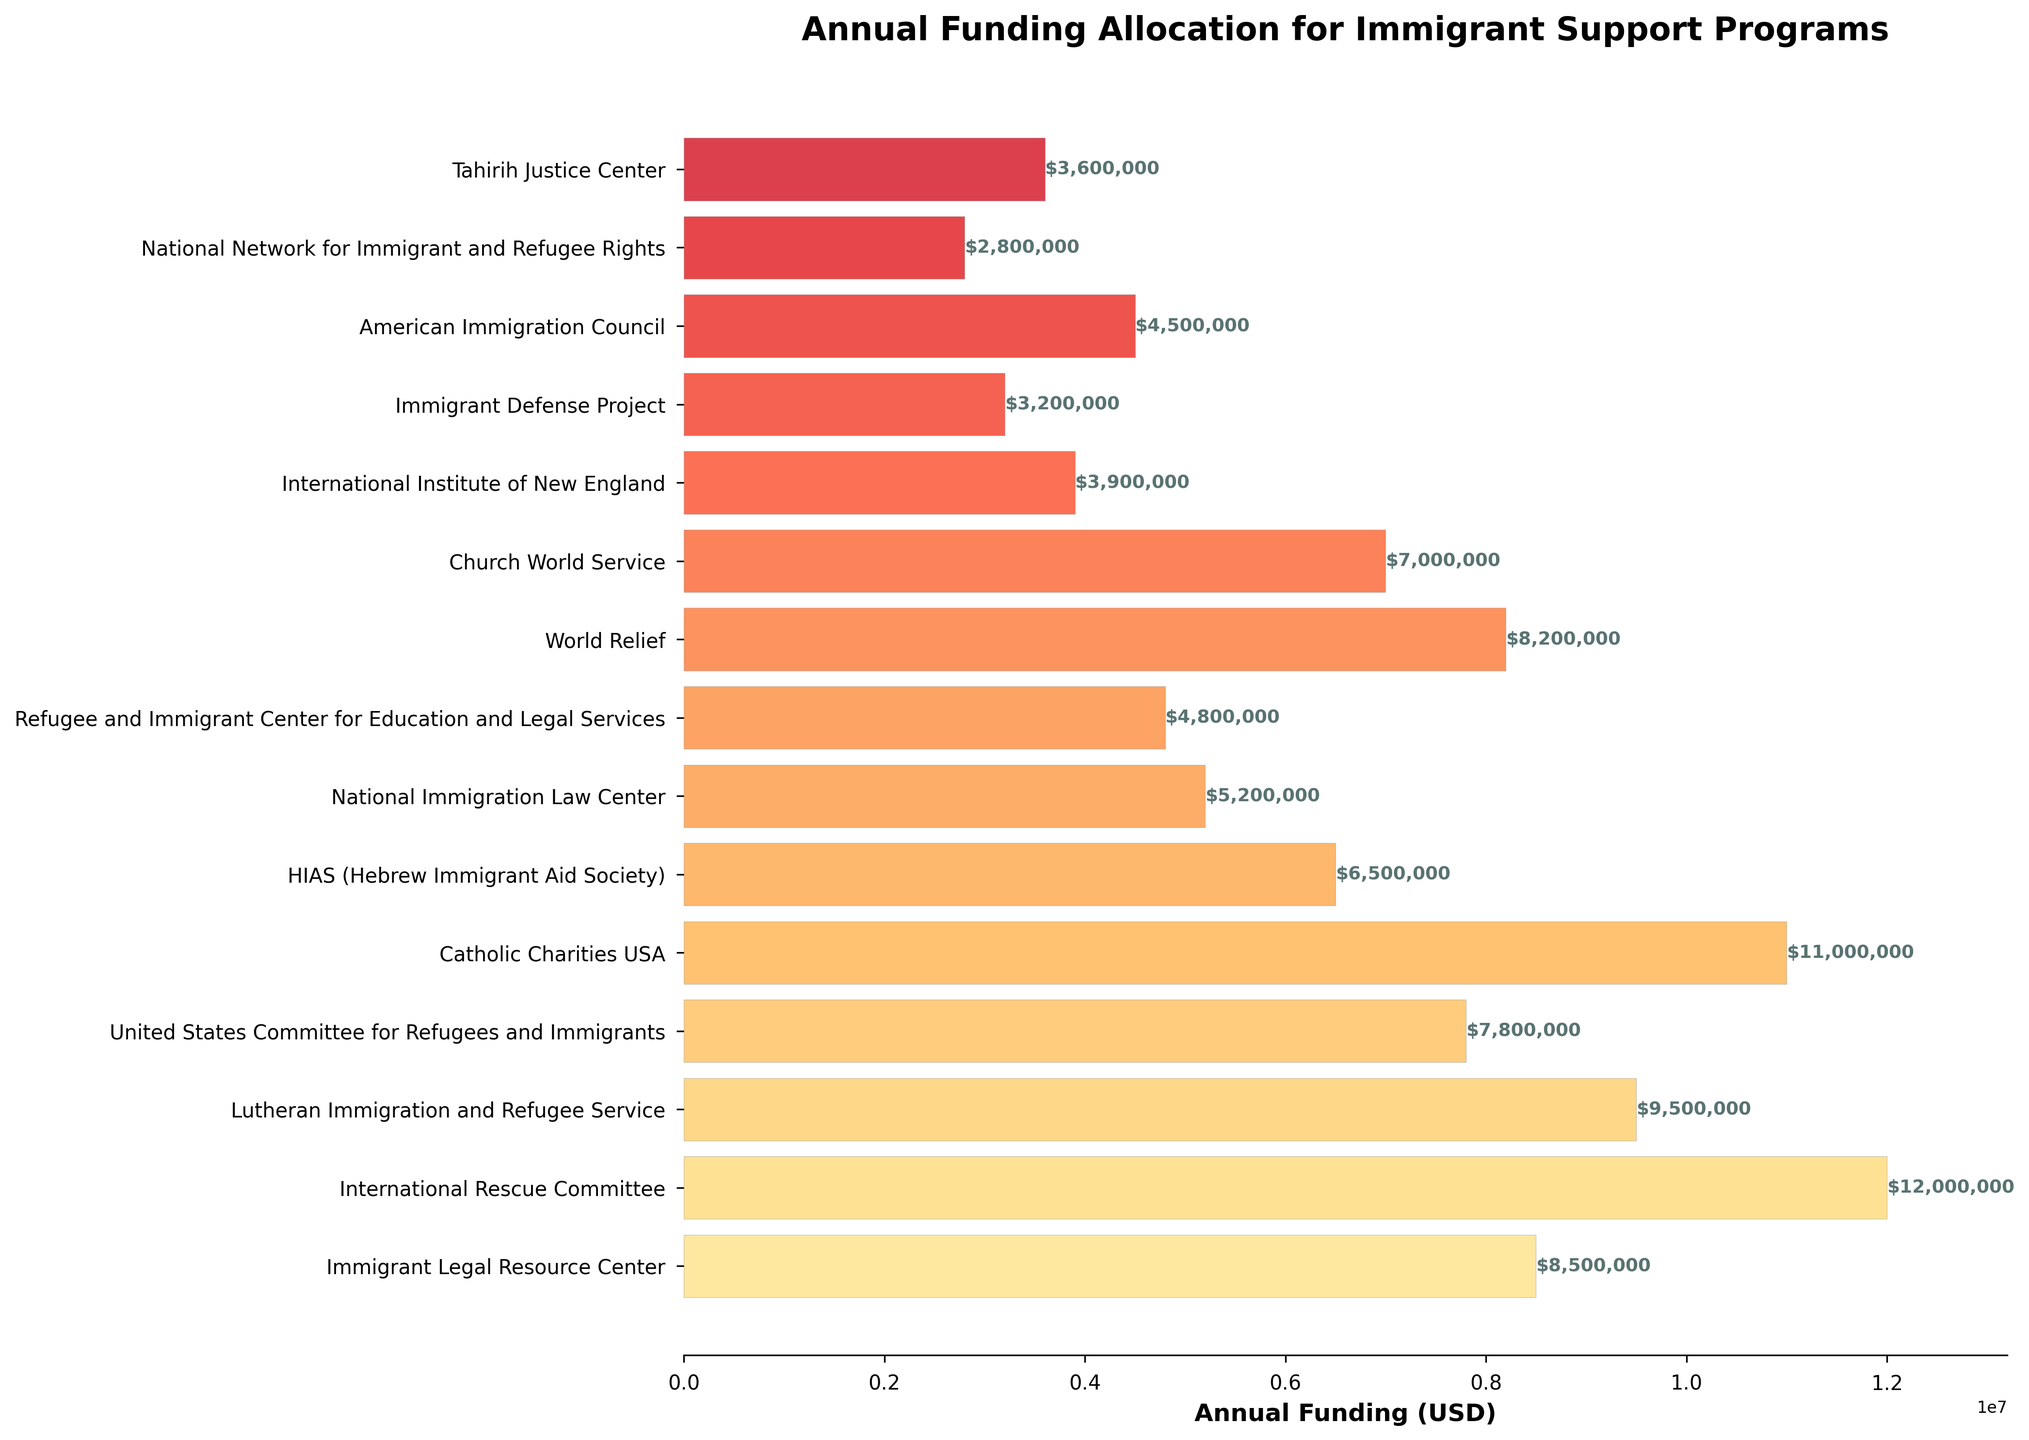What's the total annual funding for the top three organizations? First, identify the top three organizations by annual funding: International Rescue Committee ($12,000,000), Catholic Charities USA ($11,000,000), and Lutheran Immigration and Refugee Service ($9,500,000). Sum their funding: $12,000,000 + $11,000,000 + $9,500,000 = $32,500,000
Answer: $32,500,000 Which organization received less funding: Immigrant Legal Resource Center or World Relief? Compare the funding amounts: Immigrant Legal Resource Center ($8,500,000) and World Relief ($8,200,000). World Relief received less funding.
Answer: World Relief What is the average annual funding of the organizations? Sum the funding of all organizations and divide by the number of organizations. Total funding: $8,500,000 + $12,000,000 + $9,500,000 + $7,800,000 + $11,000,000 + $6,500,000 + $5,200,000 + $4,800,000 + $8,200,000 + $7,000,000 + $3,900,000 + $3,200,000 + $4,500,000 + $2,800,000 + $3,600,000 = $94,500,000. Number of organizations: 15. Average funding: $94,500,000 / 15 = $6,300,000
Answer: $6,300,000 How much more funding does the International Rescue Committee receive compared to the National Immigration Law Center? International Rescue Committee: $12,000,000. National Immigration Law Center: $5,200,000. Difference: $12,000,000 - $5,200,000 = $6,800,000
Answer: $6,800,000 Which organization has the shortest bar, and what is its funding? The organization with the shortest bar is the National Network for Immigrant and Refugee Rights. Its funding is $2,800,000.
Answer: National Network for Immigrant and Refugee Rights, $2,800,000 